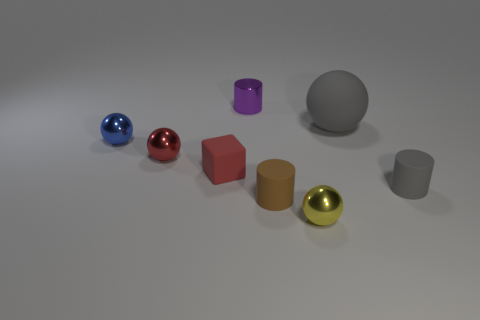Subtract all blue shiny balls. How many balls are left? 3 Subtract all red balls. How many balls are left? 3 Add 1 red matte objects. How many objects exist? 9 Subtract all green balls. Subtract all blue blocks. How many balls are left? 4 Subtract all cylinders. How many objects are left? 5 Add 1 yellow balls. How many yellow balls exist? 2 Subtract 0 blue cylinders. How many objects are left? 8 Subtract all large green shiny things. Subtract all large gray objects. How many objects are left? 7 Add 3 shiny objects. How many shiny objects are left? 7 